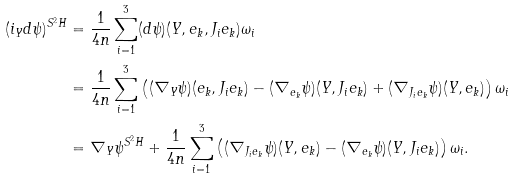<formula> <loc_0><loc_0><loc_500><loc_500>( i _ { Y } d \psi ) ^ { S ^ { 2 } H } & = \frac { 1 } { 4 n } \sum _ { i = 1 } ^ { 3 } ( d \psi ) ( Y , e _ { k } , J _ { i } e _ { k } ) \omega _ { i } \\ & = \frac { 1 } { 4 n } \sum _ { i = 1 } ^ { 3 } \left ( ( \nabla _ { Y } \psi ) ( e _ { k } , J _ { i } e _ { k } ) - ( \nabla _ { e _ { k } } \psi ) ( Y , J _ { i } e _ { k } ) + ( \nabla _ { J _ { i } e _ { k } } \psi ) ( Y , e _ { k } ) \right ) \omega _ { i } \\ & = \nabla _ { Y } \psi ^ { S ^ { 2 } H } + \frac { 1 } { 4 n } \sum _ { i = 1 } ^ { 3 } \left ( ( \nabla _ { J _ { i } e _ { k } } \psi ) ( Y , e _ { k } ) - ( \nabla _ { e _ { k } } \psi ) ( Y , J _ { i } e _ { k } ) \right ) \omega _ { i } .</formula> 